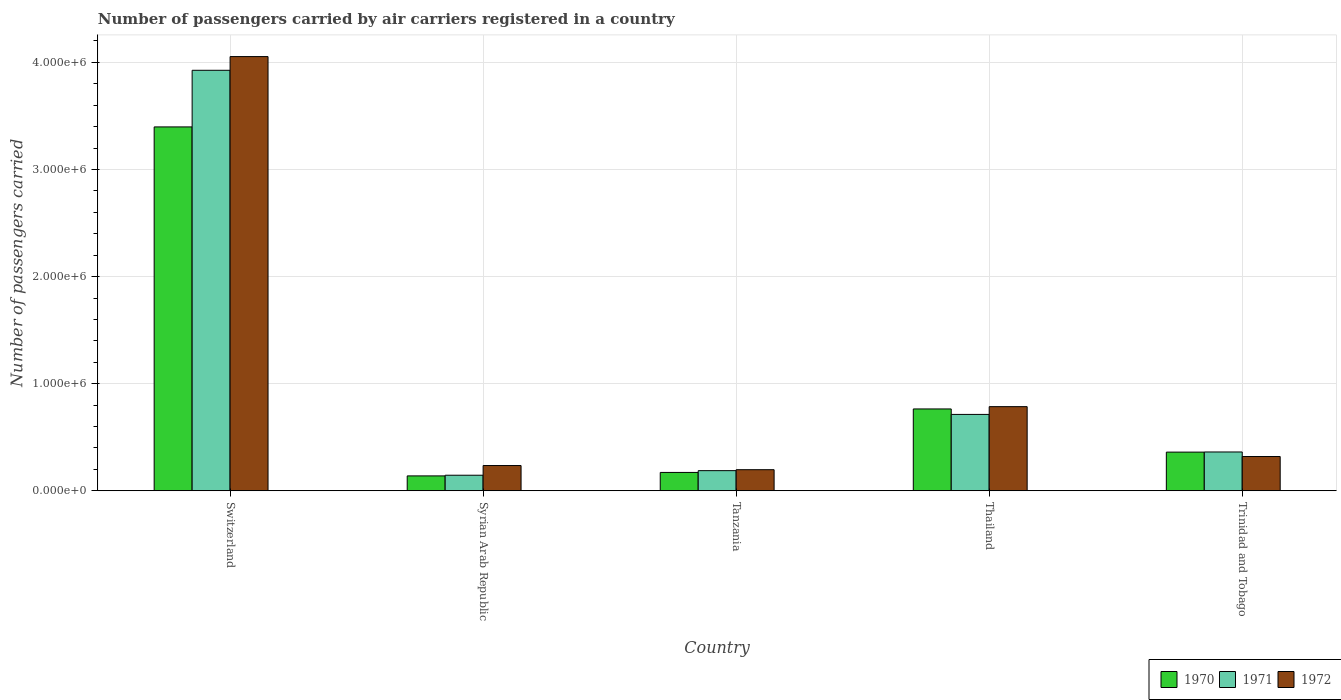How many groups of bars are there?
Ensure brevity in your answer.  5. Are the number of bars per tick equal to the number of legend labels?
Provide a succinct answer. Yes. Are the number of bars on each tick of the X-axis equal?
Your response must be concise. Yes. How many bars are there on the 4th tick from the left?
Give a very brief answer. 3. What is the label of the 1st group of bars from the left?
Give a very brief answer. Switzerland. What is the number of passengers carried by air carriers in 1971 in Syrian Arab Republic?
Ensure brevity in your answer.  1.45e+05. Across all countries, what is the maximum number of passengers carried by air carriers in 1971?
Provide a succinct answer. 3.93e+06. Across all countries, what is the minimum number of passengers carried by air carriers in 1970?
Ensure brevity in your answer.  1.39e+05. In which country was the number of passengers carried by air carriers in 1971 maximum?
Offer a very short reply. Switzerland. In which country was the number of passengers carried by air carriers in 1971 minimum?
Ensure brevity in your answer.  Syrian Arab Republic. What is the total number of passengers carried by air carriers in 1971 in the graph?
Give a very brief answer. 5.34e+06. What is the difference between the number of passengers carried by air carriers in 1970 in Tanzania and that in Trinidad and Tobago?
Give a very brief answer. -1.90e+05. What is the difference between the number of passengers carried by air carriers in 1971 in Tanzania and the number of passengers carried by air carriers in 1970 in Syrian Arab Republic?
Your response must be concise. 4.90e+04. What is the average number of passengers carried by air carriers in 1972 per country?
Your response must be concise. 1.12e+06. What is the difference between the number of passengers carried by air carriers of/in 1971 and number of passengers carried by air carriers of/in 1972 in Switzerland?
Your response must be concise. -1.28e+05. What is the ratio of the number of passengers carried by air carriers in 1970 in Switzerland to that in Thailand?
Offer a terse response. 4.45. Is the number of passengers carried by air carriers in 1972 in Syrian Arab Republic less than that in Tanzania?
Keep it short and to the point. No. Is the difference between the number of passengers carried by air carriers in 1971 in Tanzania and Trinidad and Tobago greater than the difference between the number of passengers carried by air carriers in 1972 in Tanzania and Trinidad and Tobago?
Offer a terse response. No. What is the difference between the highest and the second highest number of passengers carried by air carriers in 1970?
Offer a very short reply. 2.63e+06. What is the difference between the highest and the lowest number of passengers carried by air carriers in 1972?
Your answer should be very brief. 3.86e+06. In how many countries, is the number of passengers carried by air carriers in 1970 greater than the average number of passengers carried by air carriers in 1970 taken over all countries?
Make the answer very short. 1. Are all the bars in the graph horizontal?
Provide a succinct answer. No. Are the values on the major ticks of Y-axis written in scientific E-notation?
Keep it short and to the point. Yes. Does the graph contain any zero values?
Provide a short and direct response. No. Does the graph contain grids?
Give a very brief answer. Yes. Where does the legend appear in the graph?
Ensure brevity in your answer.  Bottom right. How many legend labels are there?
Provide a short and direct response. 3. How are the legend labels stacked?
Your response must be concise. Horizontal. What is the title of the graph?
Your answer should be compact. Number of passengers carried by air carriers registered in a country. Does "2004" appear as one of the legend labels in the graph?
Offer a very short reply. No. What is the label or title of the Y-axis?
Make the answer very short. Number of passengers carried. What is the Number of passengers carried in 1970 in Switzerland?
Your response must be concise. 3.40e+06. What is the Number of passengers carried in 1971 in Switzerland?
Keep it short and to the point. 3.93e+06. What is the Number of passengers carried in 1972 in Switzerland?
Make the answer very short. 4.05e+06. What is the Number of passengers carried in 1970 in Syrian Arab Republic?
Provide a succinct answer. 1.39e+05. What is the Number of passengers carried in 1971 in Syrian Arab Republic?
Your response must be concise. 1.45e+05. What is the Number of passengers carried of 1972 in Syrian Arab Republic?
Offer a very short reply. 2.36e+05. What is the Number of passengers carried in 1970 in Tanzania?
Ensure brevity in your answer.  1.71e+05. What is the Number of passengers carried in 1971 in Tanzania?
Make the answer very short. 1.88e+05. What is the Number of passengers carried in 1972 in Tanzania?
Your answer should be very brief. 1.97e+05. What is the Number of passengers carried of 1970 in Thailand?
Offer a very short reply. 7.64e+05. What is the Number of passengers carried in 1971 in Thailand?
Offer a very short reply. 7.13e+05. What is the Number of passengers carried in 1972 in Thailand?
Offer a very short reply. 7.86e+05. What is the Number of passengers carried in 1970 in Trinidad and Tobago?
Offer a very short reply. 3.61e+05. What is the Number of passengers carried in 1971 in Trinidad and Tobago?
Give a very brief answer. 3.62e+05. What is the Number of passengers carried in 1972 in Trinidad and Tobago?
Your response must be concise. 3.20e+05. Across all countries, what is the maximum Number of passengers carried in 1970?
Offer a very short reply. 3.40e+06. Across all countries, what is the maximum Number of passengers carried of 1971?
Make the answer very short. 3.93e+06. Across all countries, what is the maximum Number of passengers carried of 1972?
Offer a very short reply. 4.05e+06. Across all countries, what is the minimum Number of passengers carried of 1970?
Your response must be concise. 1.39e+05. Across all countries, what is the minimum Number of passengers carried of 1971?
Provide a succinct answer. 1.45e+05. Across all countries, what is the minimum Number of passengers carried in 1972?
Keep it short and to the point. 1.97e+05. What is the total Number of passengers carried of 1970 in the graph?
Your response must be concise. 4.83e+06. What is the total Number of passengers carried in 1971 in the graph?
Provide a short and direct response. 5.34e+06. What is the total Number of passengers carried in 1972 in the graph?
Ensure brevity in your answer.  5.59e+06. What is the difference between the Number of passengers carried of 1970 in Switzerland and that in Syrian Arab Republic?
Your answer should be compact. 3.26e+06. What is the difference between the Number of passengers carried in 1971 in Switzerland and that in Syrian Arab Republic?
Provide a succinct answer. 3.78e+06. What is the difference between the Number of passengers carried of 1972 in Switzerland and that in Syrian Arab Republic?
Keep it short and to the point. 3.82e+06. What is the difference between the Number of passengers carried in 1970 in Switzerland and that in Tanzania?
Keep it short and to the point. 3.23e+06. What is the difference between the Number of passengers carried of 1971 in Switzerland and that in Tanzania?
Keep it short and to the point. 3.74e+06. What is the difference between the Number of passengers carried of 1972 in Switzerland and that in Tanzania?
Provide a short and direct response. 3.86e+06. What is the difference between the Number of passengers carried in 1970 in Switzerland and that in Thailand?
Keep it short and to the point. 2.63e+06. What is the difference between the Number of passengers carried of 1971 in Switzerland and that in Thailand?
Your response must be concise. 3.21e+06. What is the difference between the Number of passengers carried in 1972 in Switzerland and that in Thailand?
Offer a terse response. 3.27e+06. What is the difference between the Number of passengers carried of 1970 in Switzerland and that in Trinidad and Tobago?
Your answer should be very brief. 3.04e+06. What is the difference between the Number of passengers carried in 1971 in Switzerland and that in Trinidad and Tobago?
Your answer should be compact. 3.56e+06. What is the difference between the Number of passengers carried in 1972 in Switzerland and that in Trinidad and Tobago?
Provide a succinct answer. 3.73e+06. What is the difference between the Number of passengers carried in 1970 in Syrian Arab Republic and that in Tanzania?
Provide a succinct answer. -3.24e+04. What is the difference between the Number of passengers carried in 1971 in Syrian Arab Republic and that in Tanzania?
Your answer should be compact. -4.27e+04. What is the difference between the Number of passengers carried in 1972 in Syrian Arab Republic and that in Tanzania?
Give a very brief answer. 3.88e+04. What is the difference between the Number of passengers carried of 1970 in Syrian Arab Republic and that in Thailand?
Give a very brief answer. -6.25e+05. What is the difference between the Number of passengers carried of 1971 in Syrian Arab Republic and that in Thailand?
Your response must be concise. -5.68e+05. What is the difference between the Number of passengers carried in 1972 in Syrian Arab Republic and that in Thailand?
Offer a very short reply. -5.50e+05. What is the difference between the Number of passengers carried of 1970 in Syrian Arab Republic and that in Trinidad and Tobago?
Offer a very short reply. -2.22e+05. What is the difference between the Number of passengers carried of 1971 in Syrian Arab Republic and that in Trinidad and Tobago?
Offer a very short reply. -2.17e+05. What is the difference between the Number of passengers carried of 1972 in Syrian Arab Republic and that in Trinidad and Tobago?
Provide a succinct answer. -8.42e+04. What is the difference between the Number of passengers carried of 1970 in Tanzania and that in Thailand?
Make the answer very short. -5.93e+05. What is the difference between the Number of passengers carried of 1971 in Tanzania and that in Thailand?
Offer a very short reply. -5.25e+05. What is the difference between the Number of passengers carried in 1972 in Tanzania and that in Thailand?
Ensure brevity in your answer.  -5.89e+05. What is the difference between the Number of passengers carried of 1970 in Tanzania and that in Trinidad and Tobago?
Your answer should be very brief. -1.90e+05. What is the difference between the Number of passengers carried of 1971 in Tanzania and that in Trinidad and Tobago?
Your answer should be compact. -1.74e+05. What is the difference between the Number of passengers carried in 1972 in Tanzania and that in Trinidad and Tobago?
Your answer should be very brief. -1.23e+05. What is the difference between the Number of passengers carried in 1970 in Thailand and that in Trinidad and Tobago?
Your answer should be compact. 4.03e+05. What is the difference between the Number of passengers carried of 1971 in Thailand and that in Trinidad and Tobago?
Ensure brevity in your answer.  3.51e+05. What is the difference between the Number of passengers carried in 1972 in Thailand and that in Trinidad and Tobago?
Offer a very short reply. 4.66e+05. What is the difference between the Number of passengers carried in 1970 in Switzerland and the Number of passengers carried in 1971 in Syrian Arab Republic?
Keep it short and to the point. 3.25e+06. What is the difference between the Number of passengers carried of 1970 in Switzerland and the Number of passengers carried of 1972 in Syrian Arab Republic?
Provide a short and direct response. 3.16e+06. What is the difference between the Number of passengers carried in 1971 in Switzerland and the Number of passengers carried in 1972 in Syrian Arab Republic?
Offer a very short reply. 3.69e+06. What is the difference between the Number of passengers carried of 1970 in Switzerland and the Number of passengers carried of 1971 in Tanzania?
Give a very brief answer. 3.21e+06. What is the difference between the Number of passengers carried of 1970 in Switzerland and the Number of passengers carried of 1972 in Tanzania?
Provide a succinct answer. 3.20e+06. What is the difference between the Number of passengers carried in 1971 in Switzerland and the Number of passengers carried in 1972 in Tanzania?
Offer a terse response. 3.73e+06. What is the difference between the Number of passengers carried in 1970 in Switzerland and the Number of passengers carried in 1971 in Thailand?
Ensure brevity in your answer.  2.68e+06. What is the difference between the Number of passengers carried in 1970 in Switzerland and the Number of passengers carried in 1972 in Thailand?
Ensure brevity in your answer.  2.61e+06. What is the difference between the Number of passengers carried of 1971 in Switzerland and the Number of passengers carried of 1972 in Thailand?
Your answer should be very brief. 3.14e+06. What is the difference between the Number of passengers carried in 1970 in Switzerland and the Number of passengers carried in 1971 in Trinidad and Tobago?
Give a very brief answer. 3.04e+06. What is the difference between the Number of passengers carried in 1970 in Switzerland and the Number of passengers carried in 1972 in Trinidad and Tobago?
Offer a very short reply. 3.08e+06. What is the difference between the Number of passengers carried of 1971 in Switzerland and the Number of passengers carried of 1972 in Trinidad and Tobago?
Your answer should be very brief. 3.61e+06. What is the difference between the Number of passengers carried in 1970 in Syrian Arab Republic and the Number of passengers carried in 1971 in Tanzania?
Make the answer very short. -4.90e+04. What is the difference between the Number of passengers carried in 1970 in Syrian Arab Republic and the Number of passengers carried in 1972 in Tanzania?
Keep it short and to the point. -5.79e+04. What is the difference between the Number of passengers carried of 1971 in Syrian Arab Republic and the Number of passengers carried of 1972 in Tanzania?
Offer a terse response. -5.16e+04. What is the difference between the Number of passengers carried of 1970 in Syrian Arab Republic and the Number of passengers carried of 1971 in Thailand?
Give a very brief answer. -5.74e+05. What is the difference between the Number of passengers carried of 1970 in Syrian Arab Republic and the Number of passengers carried of 1972 in Thailand?
Your response must be concise. -6.47e+05. What is the difference between the Number of passengers carried in 1971 in Syrian Arab Republic and the Number of passengers carried in 1972 in Thailand?
Give a very brief answer. -6.40e+05. What is the difference between the Number of passengers carried in 1970 in Syrian Arab Republic and the Number of passengers carried in 1971 in Trinidad and Tobago?
Provide a short and direct response. -2.23e+05. What is the difference between the Number of passengers carried of 1970 in Syrian Arab Republic and the Number of passengers carried of 1972 in Trinidad and Tobago?
Offer a terse response. -1.81e+05. What is the difference between the Number of passengers carried in 1971 in Syrian Arab Republic and the Number of passengers carried in 1972 in Trinidad and Tobago?
Your response must be concise. -1.75e+05. What is the difference between the Number of passengers carried of 1970 in Tanzania and the Number of passengers carried of 1971 in Thailand?
Make the answer very short. -5.42e+05. What is the difference between the Number of passengers carried of 1970 in Tanzania and the Number of passengers carried of 1972 in Thailand?
Your answer should be compact. -6.14e+05. What is the difference between the Number of passengers carried of 1971 in Tanzania and the Number of passengers carried of 1972 in Thailand?
Provide a short and direct response. -5.98e+05. What is the difference between the Number of passengers carried of 1970 in Tanzania and the Number of passengers carried of 1971 in Trinidad and Tobago?
Ensure brevity in your answer.  -1.91e+05. What is the difference between the Number of passengers carried of 1970 in Tanzania and the Number of passengers carried of 1972 in Trinidad and Tobago?
Offer a terse response. -1.48e+05. What is the difference between the Number of passengers carried in 1971 in Tanzania and the Number of passengers carried in 1972 in Trinidad and Tobago?
Give a very brief answer. -1.32e+05. What is the difference between the Number of passengers carried of 1970 in Thailand and the Number of passengers carried of 1971 in Trinidad and Tobago?
Make the answer very short. 4.02e+05. What is the difference between the Number of passengers carried of 1970 in Thailand and the Number of passengers carried of 1972 in Trinidad and Tobago?
Offer a very short reply. 4.44e+05. What is the difference between the Number of passengers carried of 1971 in Thailand and the Number of passengers carried of 1972 in Trinidad and Tobago?
Offer a very short reply. 3.93e+05. What is the average Number of passengers carried of 1970 per country?
Make the answer very short. 9.67e+05. What is the average Number of passengers carried in 1971 per country?
Provide a short and direct response. 1.07e+06. What is the average Number of passengers carried of 1972 per country?
Your response must be concise. 1.12e+06. What is the difference between the Number of passengers carried of 1970 and Number of passengers carried of 1971 in Switzerland?
Your answer should be compact. -5.29e+05. What is the difference between the Number of passengers carried in 1970 and Number of passengers carried in 1972 in Switzerland?
Your response must be concise. -6.57e+05. What is the difference between the Number of passengers carried in 1971 and Number of passengers carried in 1972 in Switzerland?
Provide a succinct answer. -1.28e+05. What is the difference between the Number of passengers carried of 1970 and Number of passengers carried of 1971 in Syrian Arab Republic?
Keep it short and to the point. -6300. What is the difference between the Number of passengers carried of 1970 and Number of passengers carried of 1972 in Syrian Arab Republic?
Provide a short and direct response. -9.67e+04. What is the difference between the Number of passengers carried of 1971 and Number of passengers carried of 1972 in Syrian Arab Republic?
Offer a terse response. -9.04e+04. What is the difference between the Number of passengers carried in 1970 and Number of passengers carried in 1971 in Tanzania?
Your response must be concise. -1.66e+04. What is the difference between the Number of passengers carried in 1970 and Number of passengers carried in 1972 in Tanzania?
Offer a very short reply. -2.55e+04. What is the difference between the Number of passengers carried of 1971 and Number of passengers carried of 1972 in Tanzania?
Provide a succinct answer. -8900. What is the difference between the Number of passengers carried in 1970 and Number of passengers carried in 1971 in Thailand?
Your response must be concise. 5.11e+04. What is the difference between the Number of passengers carried of 1970 and Number of passengers carried of 1972 in Thailand?
Keep it short and to the point. -2.14e+04. What is the difference between the Number of passengers carried in 1971 and Number of passengers carried in 1972 in Thailand?
Offer a terse response. -7.25e+04. What is the difference between the Number of passengers carried of 1970 and Number of passengers carried of 1971 in Trinidad and Tobago?
Keep it short and to the point. -1300. What is the difference between the Number of passengers carried in 1970 and Number of passengers carried in 1972 in Trinidad and Tobago?
Give a very brief answer. 4.12e+04. What is the difference between the Number of passengers carried of 1971 and Number of passengers carried of 1972 in Trinidad and Tobago?
Offer a terse response. 4.25e+04. What is the ratio of the Number of passengers carried in 1970 in Switzerland to that in Syrian Arab Republic?
Provide a short and direct response. 24.44. What is the ratio of the Number of passengers carried in 1971 in Switzerland to that in Syrian Arab Republic?
Keep it short and to the point. 27.02. What is the ratio of the Number of passengers carried in 1972 in Switzerland to that in Syrian Arab Republic?
Make the answer very short. 17.2. What is the ratio of the Number of passengers carried in 1970 in Switzerland to that in Tanzania?
Make the answer very short. 19.82. What is the ratio of the Number of passengers carried of 1971 in Switzerland to that in Tanzania?
Your answer should be very brief. 20.88. What is the ratio of the Number of passengers carried in 1972 in Switzerland to that in Tanzania?
Ensure brevity in your answer.  20.59. What is the ratio of the Number of passengers carried in 1970 in Switzerland to that in Thailand?
Your answer should be compact. 4.45. What is the ratio of the Number of passengers carried in 1971 in Switzerland to that in Thailand?
Provide a succinct answer. 5.51. What is the ratio of the Number of passengers carried in 1972 in Switzerland to that in Thailand?
Offer a very short reply. 5.16. What is the ratio of the Number of passengers carried in 1970 in Switzerland to that in Trinidad and Tobago?
Keep it short and to the point. 9.41. What is the ratio of the Number of passengers carried in 1971 in Switzerland to that in Trinidad and Tobago?
Keep it short and to the point. 10.83. What is the ratio of the Number of passengers carried in 1972 in Switzerland to that in Trinidad and Tobago?
Your answer should be very brief. 12.67. What is the ratio of the Number of passengers carried of 1970 in Syrian Arab Republic to that in Tanzania?
Ensure brevity in your answer.  0.81. What is the ratio of the Number of passengers carried in 1971 in Syrian Arab Republic to that in Tanzania?
Offer a terse response. 0.77. What is the ratio of the Number of passengers carried in 1972 in Syrian Arab Republic to that in Tanzania?
Provide a short and direct response. 1.2. What is the ratio of the Number of passengers carried in 1970 in Syrian Arab Republic to that in Thailand?
Your response must be concise. 0.18. What is the ratio of the Number of passengers carried of 1971 in Syrian Arab Republic to that in Thailand?
Your response must be concise. 0.2. What is the ratio of the Number of passengers carried of 1972 in Syrian Arab Republic to that in Thailand?
Your answer should be compact. 0.3. What is the ratio of the Number of passengers carried in 1970 in Syrian Arab Republic to that in Trinidad and Tobago?
Offer a very short reply. 0.38. What is the ratio of the Number of passengers carried in 1971 in Syrian Arab Republic to that in Trinidad and Tobago?
Offer a very short reply. 0.4. What is the ratio of the Number of passengers carried of 1972 in Syrian Arab Republic to that in Trinidad and Tobago?
Your answer should be compact. 0.74. What is the ratio of the Number of passengers carried of 1970 in Tanzania to that in Thailand?
Ensure brevity in your answer.  0.22. What is the ratio of the Number of passengers carried of 1971 in Tanzania to that in Thailand?
Ensure brevity in your answer.  0.26. What is the ratio of the Number of passengers carried of 1972 in Tanzania to that in Thailand?
Your answer should be very brief. 0.25. What is the ratio of the Number of passengers carried in 1970 in Tanzania to that in Trinidad and Tobago?
Your response must be concise. 0.47. What is the ratio of the Number of passengers carried of 1971 in Tanzania to that in Trinidad and Tobago?
Offer a very short reply. 0.52. What is the ratio of the Number of passengers carried in 1972 in Tanzania to that in Trinidad and Tobago?
Keep it short and to the point. 0.62. What is the ratio of the Number of passengers carried in 1970 in Thailand to that in Trinidad and Tobago?
Offer a terse response. 2.12. What is the ratio of the Number of passengers carried in 1971 in Thailand to that in Trinidad and Tobago?
Provide a short and direct response. 1.97. What is the ratio of the Number of passengers carried in 1972 in Thailand to that in Trinidad and Tobago?
Your answer should be very brief. 2.46. What is the difference between the highest and the second highest Number of passengers carried of 1970?
Offer a terse response. 2.63e+06. What is the difference between the highest and the second highest Number of passengers carried in 1971?
Offer a terse response. 3.21e+06. What is the difference between the highest and the second highest Number of passengers carried of 1972?
Provide a short and direct response. 3.27e+06. What is the difference between the highest and the lowest Number of passengers carried in 1970?
Keep it short and to the point. 3.26e+06. What is the difference between the highest and the lowest Number of passengers carried of 1971?
Offer a terse response. 3.78e+06. What is the difference between the highest and the lowest Number of passengers carried of 1972?
Your answer should be compact. 3.86e+06. 